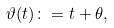<formula> <loc_0><loc_0><loc_500><loc_500>\vartheta ( t ) \colon = t + \theta ,</formula> 